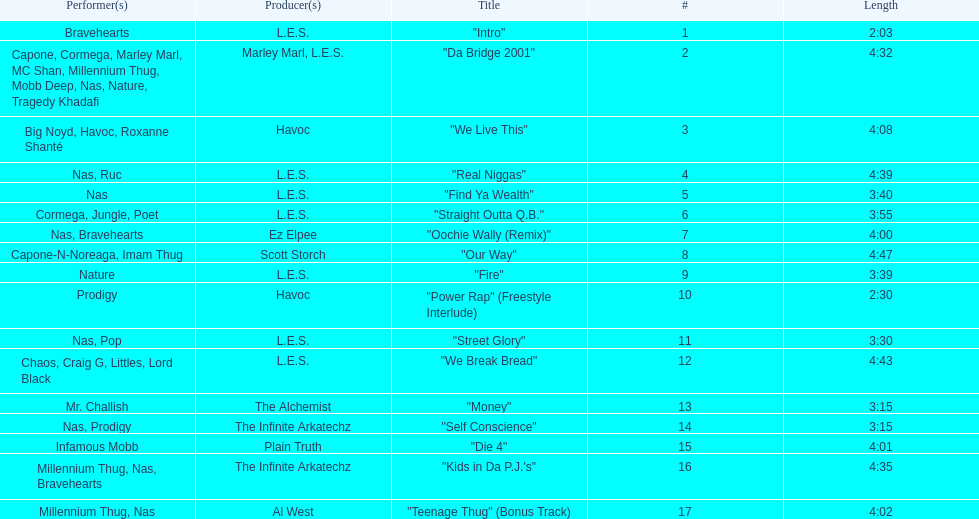I'm looking to parse the entire table for insights. Could you assist me with that? {'header': ['Performer(s)', 'Producer(s)', 'Title', '#', 'Length'], 'rows': [['Bravehearts', 'L.E.S.', '"Intro"', '1', '2:03'], ['Capone, Cormega, Marley Marl, MC Shan, Millennium Thug, Mobb Deep, Nas, Nature, Tragedy Khadafi', 'Marley Marl, L.E.S.', '"Da Bridge 2001"', '2', '4:32'], ['Big Noyd, Havoc, Roxanne Shanté', 'Havoc', '"We Live This"', '3', '4:08'], ['Nas, Ruc', 'L.E.S.', '"Real Niggas"', '4', '4:39'], ['Nas', 'L.E.S.', '"Find Ya Wealth"', '5', '3:40'], ['Cormega, Jungle, Poet', 'L.E.S.', '"Straight Outta Q.B."', '6', '3:55'], ['Nas, Bravehearts', 'Ez Elpee', '"Oochie Wally (Remix)"', '7', '4:00'], ['Capone-N-Noreaga, Imam Thug', 'Scott Storch', '"Our Way"', '8', '4:47'], ['Nature', 'L.E.S.', '"Fire"', '9', '3:39'], ['Prodigy', 'Havoc', '"Power Rap" (Freestyle Interlude)', '10', '2:30'], ['Nas, Pop', 'L.E.S.', '"Street Glory"', '11', '3:30'], ['Chaos, Craig G, Littles, Lord Black', 'L.E.S.', '"We Break Bread"', '12', '4:43'], ['Mr. Challish', 'The Alchemist', '"Money"', '13', '3:15'], ['Nas, Prodigy', 'The Infinite Arkatechz', '"Self Conscience"', '14', '3:15'], ['Infamous Mobb', 'Plain Truth', '"Die 4"', '15', '4:01'], ['Millennium Thug, Nas, Bravehearts', 'The Infinite Arkatechz', '"Kids in Da P.J.\'s"', '16', '4:35'], ['Millennium Thug, Nas', 'Al West', '"Teenage Thug" (Bonus Track)', '17', '4:02']]} Which track is longer, "money" or "die 4"? "Die 4". 